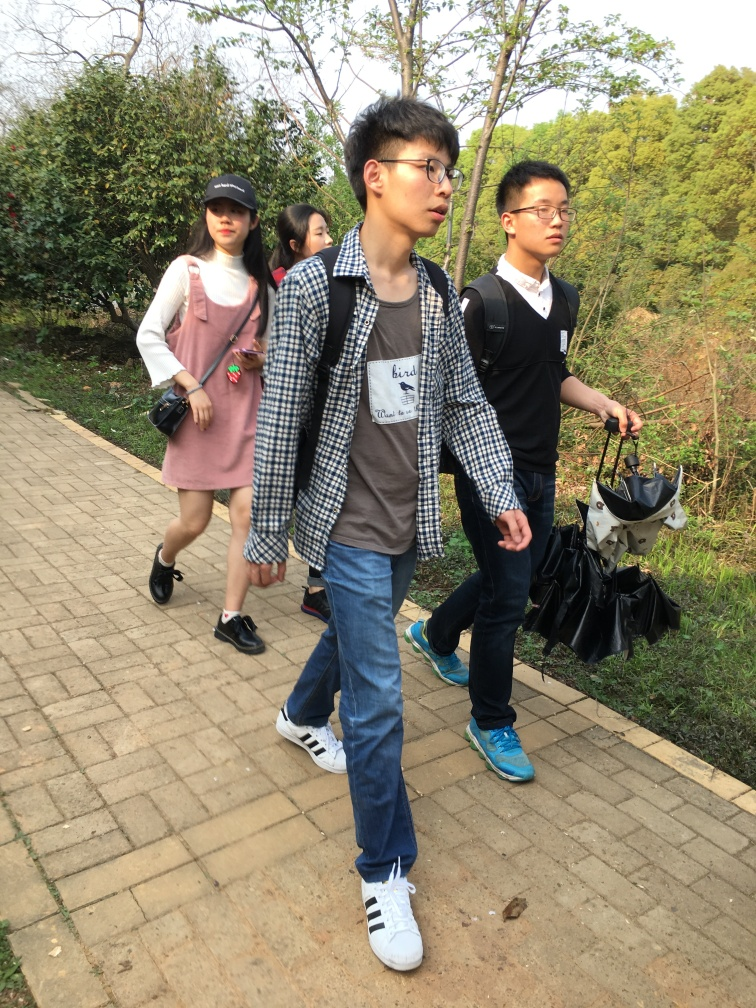Is the brightness level appropriate in the photo? Yes, the brightness level in the photo is quite appropriate. It allows for clear visibility of individuals and the surrounding environment, highlighting details without any overexposure or underexposure which could detract from the quality of the image. 